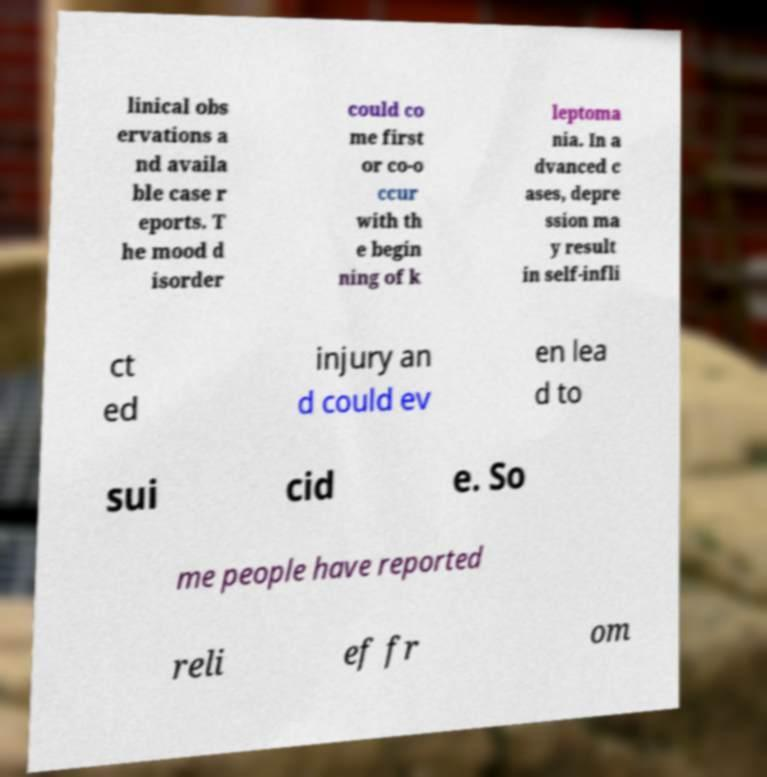Please identify and transcribe the text found in this image. linical obs ervations a nd availa ble case r eports. T he mood d isorder could co me first or co-o ccur with th e begin ning of k leptoma nia. In a dvanced c ases, depre ssion ma y result in self-infli ct ed injury an d could ev en lea d to sui cid e. So me people have reported reli ef fr om 